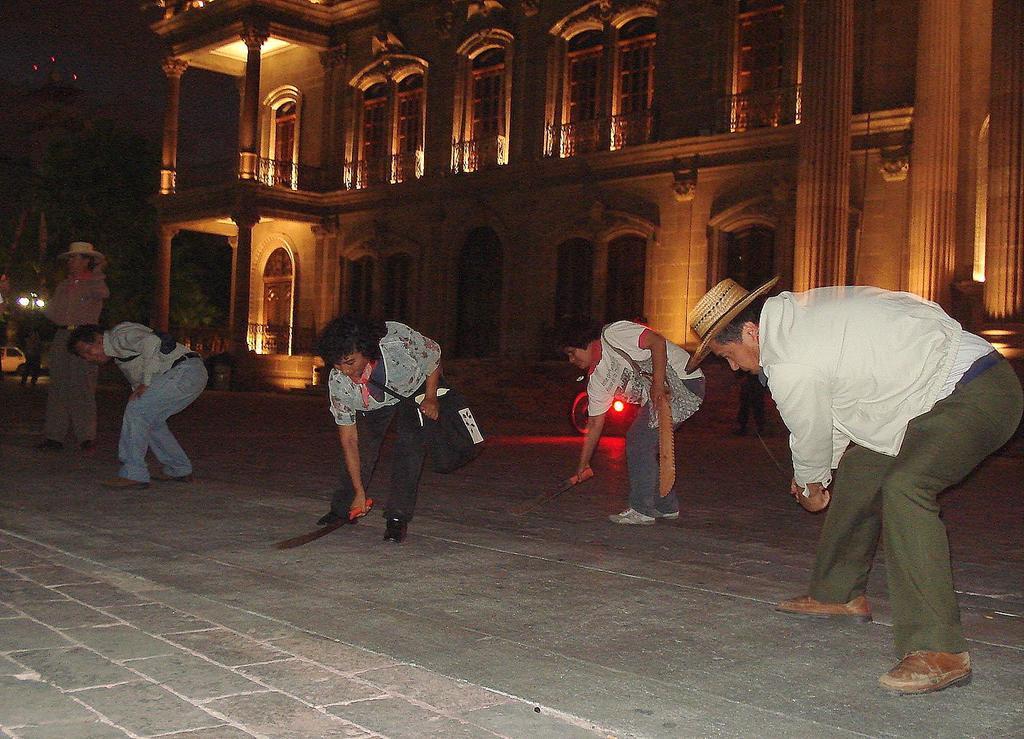In one or two sentences, can you explain what this image depicts? In this image we can see four people bending and cleaning roads with broomsticks. On the left there is a person standing. In the background there is a building and lights. At the bottom there is a road and we can see vehicles. 